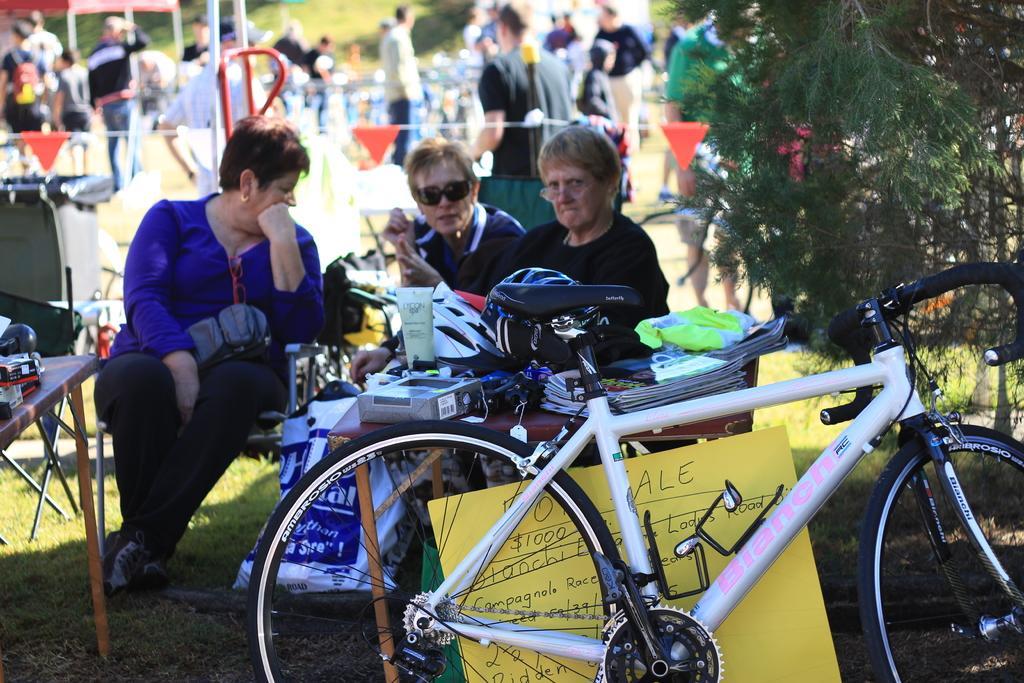Could you give a brief overview of what you see in this image? In this image I can see a group of people were few of them are sitting on a chair. I can also see cycle and a tree. I can see a box on a table and few more items on it. 